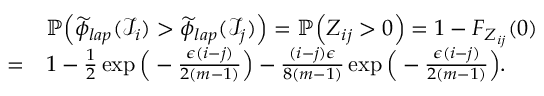<formula> <loc_0><loc_0><loc_500><loc_500>\begin{array} { r l } & { \mathbb { P } \left ( \widetilde { \phi } _ { l a p } ( \mathcal { I } _ { i } ) > \widetilde { \phi } _ { l a p } ( \mathcal { I } _ { j } ) \right ) = \mathbb { P } \left ( Z _ { i j } > 0 \right ) = 1 - F _ { Z _ { i j } } ( 0 ) } \\ { = } & { 1 - \frac { 1 } { 2 } \exp \left ( - \frac { \epsilon ( i - j ) } { 2 ( m - 1 ) } \right ) - \frac { ( i - j ) \epsilon } { 8 ( m - 1 ) } \exp \left ( - \frac { \epsilon ( i - j ) } { 2 ( m - 1 ) } \right ) . } \end{array}</formula> 